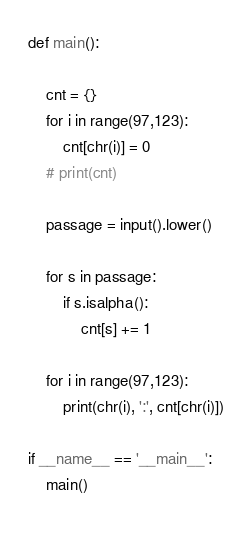<code> <loc_0><loc_0><loc_500><loc_500><_Python_>def main():

    cnt = {}
    for i in range(97,123):
        cnt[chr(i)] = 0
    # print(cnt)

    passage = input().lower()

    for s in passage:
        if s.isalpha():
            cnt[s] += 1

    for i in range(97,123):
        print(chr(i), ':', cnt[chr(i)])

if __name__ == '__main__':
    main()
    
</code> 